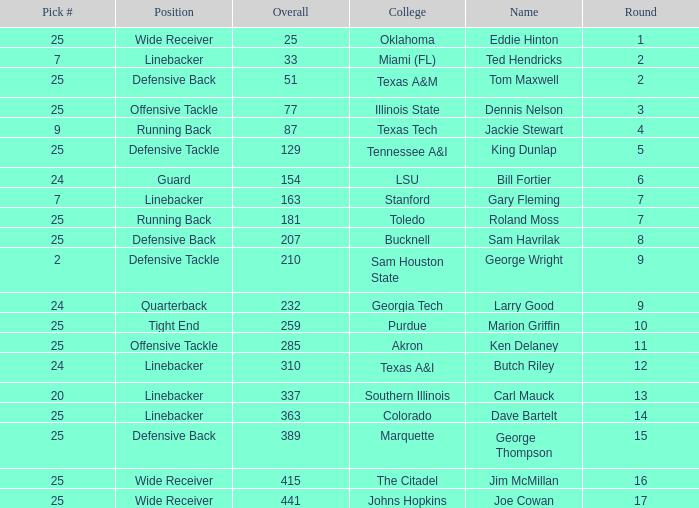Pick # of 25, and an Overall of 207 has what name? Sam Havrilak. 